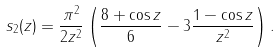Convert formula to latex. <formula><loc_0><loc_0><loc_500><loc_500>s _ { 2 } ( z ) = \frac { \pi ^ { 2 } } { 2 z ^ { 2 } } \left ( \frac { 8 + \cos z } { 6 } - 3 \frac { 1 - \cos z } { z ^ { 2 } } \right ) .</formula> 